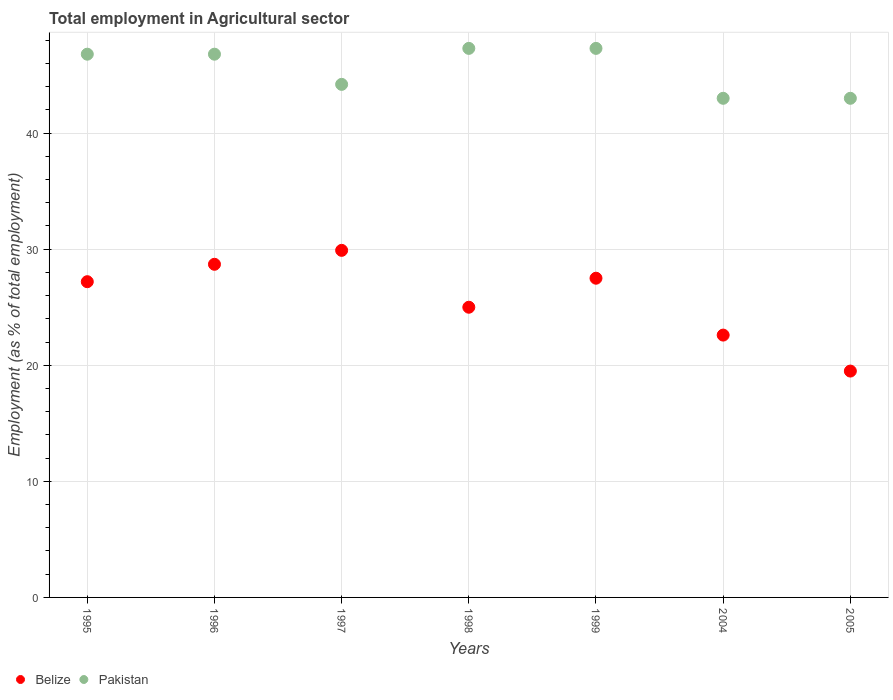Is the number of dotlines equal to the number of legend labels?
Offer a very short reply. Yes. What is the employment in agricultural sector in Pakistan in 1998?
Your answer should be compact. 47.3. Across all years, what is the maximum employment in agricultural sector in Belize?
Give a very brief answer. 29.9. Across all years, what is the minimum employment in agricultural sector in Belize?
Your answer should be very brief. 19.5. In which year was the employment in agricultural sector in Belize maximum?
Your answer should be compact. 1997. In which year was the employment in agricultural sector in Belize minimum?
Your response must be concise. 2005. What is the total employment in agricultural sector in Pakistan in the graph?
Your answer should be compact. 318.4. What is the difference between the employment in agricultural sector in Belize in 1995 and that in 1999?
Make the answer very short. -0.3. What is the difference between the employment in agricultural sector in Pakistan in 1998 and the employment in agricultural sector in Belize in 1996?
Keep it short and to the point. 18.6. What is the average employment in agricultural sector in Belize per year?
Keep it short and to the point. 25.77. In the year 1995, what is the difference between the employment in agricultural sector in Belize and employment in agricultural sector in Pakistan?
Keep it short and to the point. -19.6. What is the ratio of the employment in agricultural sector in Belize in 1995 to that in 1999?
Offer a terse response. 0.99. What is the difference between the highest and the second highest employment in agricultural sector in Belize?
Ensure brevity in your answer.  1.2. What is the difference between the highest and the lowest employment in agricultural sector in Belize?
Offer a terse response. 10.4. In how many years, is the employment in agricultural sector in Pakistan greater than the average employment in agricultural sector in Pakistan taken over all years?
Your answer should be very brief. 4. Is the employment in agricultural sector in Belize strictly greater than the employment in agricultural sector in Pakistan over the years?
Give a very brief answer. No. How many years are there in the graph?
Your answer should be compact. 7. What is the difference between two consecutive major ticks on the Y-axis?
Provide a succinct answer. 10. Are the values on the major ticks of Y-axis written in scientific E-notation?
Offer a very short reply. No. Where does the legend appear in the graph?
Your answer should be very brief. Bottom left. How are the legend labels stacked?
Make the answer very short. Horizontal. What is the title of the graph?
Make the answer very short. Total employment in Agricultural sector. What is the label or title of the X-axis?
Offer a very short reply. Years. What is the label or title of the Y-axis?
Keep it short and to the point. Employment (as % of total employment). What is the Employment (as % of total employment) of Belize in 1995?
Your answer should be compact. 27.2. What is the Employment (as % of total employment) of Pakistan in 1995?
Ensure brevity in your answer.  46.8. What is the Employment (as % of total employment) in Belize in 1996?
Your answer should be compact. 28.7. What is the Employment (as % of total employment) in Pakistan in 1996?
Offer a very short reply. 46.8. What is the Employment (as % of total employment) of Belize in 1997?
Provide a short and direct response. 29.9. What is the Employment (as % of total employment) in Pakistan in 1997?
Provide a short and direct response. 44.2. What is the Employment (as % of total employment) in Pakistan in 1998?
Offer a terse response. 47.3. What is the Employment (as % of total employment) of Pakistan in 1999?
Your answer should be compact. 47.3. What is the Employment (as % of total employment) in Belize in 2004?
Offer a terse response. 22.6. What is the Employment (as % of total employment) of Pakistan in 2004?
Ensure brevity in your answer.  43. What is the Employment (as % of total employment) of Belize in 2005?
Your response must be concise. 19.5. Across all years, what is the maximum Employment (as % of total employment) of Belize?
Your response must be concise. 29.9. Across all years, what is the maximum Employment (as % of total employment) in Pakistan?
Offer a terse response. 47.3. Across all years, what is the minimum Employment (as % of total employment) of Belize?
Offer a very short reply. 19.5. Across all years, what is the minimum Employment (as % of total employment) of Pakistan?
Provide a succinct answer. 43. What is the total Employment (as % of total employment) of Belize in the graph?
Provide a short and direct response. 180.4. What is the total Employment (as % of total employment) in Pakistan in the graph?
Give a very brief answer. 318.4. What is the difference between the Employment (as % of total employment) of Belize in 1995 and that in 1996?
Offer a very short reply. -1.5. What is the difference between the Employment (as % of total employment) in Pakistan in 1995 and that in 1996?
Ensure brevity in your answer.  0. What is the difference between the Employment (as % of total employment) of Belize in 1995 and that in 1997?
Keep it short and to the point. -2.7. What is the difference between the Employment (as % of total employment) in Belize in 1995 and that in 1998?
Offer a terse response. 2.2. What is the difference between the Employment (as % of total employment) of Belize in 1995 and that in 1999?
Offer a terse response. -0.3. What is the difference between the Employment (as % of total employment) in Pakistan in 1995 and that in 1999?
Ensure brevity in your answer.  -0.5. What is the difference between the Employment (as % of total employment) of Pakistan in 1995 and that in 2004?
Your answer should be compact. 3.8. What is the difference between the Employment (as % of total employment) in Belize in 1995 and that in 2005?
Your answer should be compact. 7.7. What is the difference between the Employment (as % of total employment) of Belize in 1996 and that in 2004?
Make the answer very short. 6.1. What is the difference between the Employment (as % of total employment) of Pakistan in 1996 and that in 2004?
Provide a short and direct response. 3.8. What is the difference between the Employment (as % of total employment) of Belize in 1996 and that in 2005?
Offer a terse response. 9.2. What is the difference between the Employment (as % of total employment) in Pakistan in 1996 and that in 2005?
Offer a terse response. 3.8. What is the difference between the Employment (as % of total employment) of Belize in 1997 and that in 1998?
Offer a terse response. 4.9. What is the difference between the Employment (as % of total employment) of Belize in 1997 and that in 2004?
Offer a terse response. 7.3. What is the difference between the Employment (as % of total employment) in Pakistan in 1997 and that in 2005?
Your answer should be very brief. 1.2. What is the difference between the Employment (as % of total employment) in Belize in 1998 and that in 1999?
Your answer should be compact. -2.5. What is the difference between the Employment (as % of total employment) in Belize in 1999 and that in 2004?
Offer a terse response. 4.9. What is the difference between the Employment (as % of total employment) of Pakistan in 1999 and that in 2004?
Provide a short and direct response. 4.3. What is the difference between the Employment (as % of total employment) of Belize in 2004 and that in 2005?
Provide a short and direct response. 3.1. What is the difference between the Employment (as % of total employment) in Pakistan in 2004 and that in 2005?
Offer a very short reply. 0. What is the difference between the Employment (as % of total employment) of Belize in 1995 and the Employment (as % of total employment) of Pakistan in 1996?
Give a very brief answer. -19.6. What is the difference between the Employment (as % of total employment) in Belize in 1995 and the Employment (as % of total employment) in Pakistan in 1998?
Make the answer very short. -20.1. What is the difference between the Employment (as % of total employment) of Belize in 1995 and the Employment (as % of total employment) of Pakistan in 1999?
Your response must be concise. -20.1. What is the difference between the Employment (as % of total employment) in Belize in 1995 and the Employment (as % of total employment) in Pakistan in 2004?
Your answer should be compact. -15.8. What is the difference between the Employment (as % of total employment) in Belize in 1995 and the Employment (as % of total employment) in Pakistan in 2005?
Make the answer very short. -15.8. What is the difference between the Employment (as % of total employment) in Belize in 1996 and the Employment (as % of total employment) in Pakistan in 1997?
Provide a short and direct response. -15.5. What is the difference between the Employment (as % of total employment) in Belize in 1996 and the Employment (as % of total employment) in Pakistan in 1998?
Provide a succinct answer. -18.6. What is the difference between the Employment (as % of total employment) in Belize in 1996 and the Employment (as % of total employment) in Pakistan in 1999?
Your answer should be very brief. -18.6. What is the difference between the Employment (as % of total employment) in Belize in 1996 and the Employment (as % of total employment) in Pakistan in 2004?
Ensure brevity in your answer.  -14.3. What is the difference between the Employment (as % of total employment) of Belize in 1996 and the Employment (as % of total employment) of Pakistan in 2005?
Your response must be concise. -14.3. What is the difference between the Employment (as % of total employment) in Belize in 1997 and the Employment (as % of total employment) in Pakistan in 1998?
Keep it short and to the point. -17.4. What is the difference between the Employment (as % of total employment) of Belize in 1997 and the Employment (as % of total employment) of Pakistan in 1999?
Offer a terse response. -17.4. What is the difference between the Employment (as % of total employment) of Belize in 1997 and the Employment (as % of total employment) of Pakistan in 2004?
Make the answer very short. -13.1. What is the difference between the Employment (as % of total employment) of Belize in 1997 and the Employment (as % of total employment) of Pakistan in 2005?
Offer a terse response. -13.1. What is the difference between the Employment (as % of total employment) of Belize in 1998 and the Employment (as % of total employment) of Pakistan in 1999?
Your response must be concise. -22.3. What is the difference between the Employment (as % of total employment) in Belize in 1998 and the Employment (as % of total employment) in Pakistan in 2004?
Give a very brief answer. -18. What is the difference between the Employment (as % of total employment) in Belize in 1999 and the Employment (as % of total employment) in Pakistan in 2004?
Keep it short and to the point. -15.5. What is the difference between the Employment (as % of total employment) in Belize in 1999 and the Employment (as % of total employment) in Pakistan in 2005?
Provide a succinct answer. -15.5. What is the difference between the Employment (as % of total employment) in Belize in 2004 and the Employment (as % of total employment) in Pakistan in 2005?
Ensure brevity in your answer.  -20.4. What is the average Employment (as % of total employment) in Belize per year?
Give a very brief answer. 25.77. What is the average Employment (as % of total employment) of Pakistan per year?
Your answer should be compact. 45.49. In the year 1995, what is the difference between the Employment (as % of total employment) of Belize and Employment (as % of total employment) of Pakistan?
Your answer should be compact. -19.6. In the year 1996, what is the difference between the Employment (as % of total employment) in Belize and Employment (as % of total employment) in Pakistan?
Ensure brevity in your answer.  -18.1. In the year 1997, what is the difference between the Employment (as % of total employment) in Belize and Employment (as % of total employment) in Pakistan?
Offer a terse response. -14.3. In the year 1998, what is the difference between the Employment (as % of total employment) in Belize and Employment (as % of total employment) in Pakistan?
Provide a short and direct response. -22.3. In the year 1999, what is the difference between the Employment (as % of total employment) in Belize and Employment (as % of total employment) in Pakistan?
Give a very brief answer. -19.8. In the year 2004, what is the difference between the Employment (as % of total employment) of Belize and Employment (as % of total employment) of Pakistan?
Offer a very short reply. -20.4. In the year 2005, what is the difference between the Employment (as % of total employment) of Belize and Employment (as % of total employment) of Pakistan?
Give a very brief answer. -23.5. What is the ratio of the Employment (as % of total employment) of Belize in 1995 to that in 1996?
Keep it short and to the point. 0.95. What is the ratio of the Employment (as % of total employment) in Belize in 1995 to that in 1997?
Your answer should be compact. 0.91. What is the ratio of the Employment (as % of total employment) of Pakistan in 1995 to that in 1997?
Make the answer very short. 1.06. What is the ratio of the Employment (as % of total employment) in Belize in 1995 to that in 1998?
Keep it short and to the point. 1.09. What is the ratio of the Employment (as % of total employment) in Pakistan in 1995 to that in 1998?
Keep it short and to the point. 0.99. What is the ratio of the Employment (as % of total employment) in Belize in 1995 to that in 1999?
Your answer should be compact. 0.99. What is the ratio of the Employment (as % of total employment) of Pakistan in 1995 to that in 1999?
Your answer should be very brief. 0.99. What is the ratio of the Employment (as % of total employment) of Belize in 1995 to that in 2004?
Make the answer very short. 1.2. What is the ratio of the Employment (as % of total employment) in Pakistan in 1995 to that in 2004?
Your response must be concise. 1.09. What is the ratio of the Employment (as % of total employment) of Belize in 1995 to that in 2005?
Make the answer very short. 1.39. What is the ratio of the Employment (as % of total employment) in Pakistan in 1995 to that in 2005?
Keep it short and to the point. 1.09. What is the ratio of the Employment (as % of total employment) of Belize in 1996 to that in 1997?
Your response must be concise. 0.96. What is the ratio of the Employment (as % of total employment) of Pakistan in 1996 to that in 1997?
Provide a succinct answer. 1.06. What is the ratio of the Employment (as % of total employment) in Belize in 1996 to that in 1998?
Your response must be concise. 1.15. What is the ratio of the Employment (as % of total employment) in Belize in 1996 to that in 1999?
Give a very brief answer. 1.04. What is the ratio of the Employment (as % of total employment) of Pakistan in 1996 to that in 1999?
Your response must be concise. 0.99. What is the ratio of the Employment (as % of total employment) of Belize in 1996 to that in 2004?
Offer a very short reply. 1.27. What is the ratio of the Employment (as % of total employment) of Pakistan in 1996 to that in 2004?
Offer a very short reply. 1.09. What is the ratio of the Employment (as % of total employment) in Belize in 1996 to that in 2005?
Keep it short and to the point. 1.47. What is the ratio of the Employment (as % of total employment) in Pakistan in 1996 to that in 2005?
Ensure brevity in your answer.  1.09. What is the ratio of the Employment (as % of total employment) in Belize in 1997 to that in 1998?
Offer a very short reply. 1.2. What is the ratio of the Employment (as % of total employment) of Pakistan in 1997 to that in 1998?
Your answer should be compact. 0.93. What is the ratio of the Employment (as % of total employment) of Belize in 1997 to that in 1999?
Make the answer very short. 1.09. What is the ratio of the Employment (as % of total employment) in Pakistan in 1997 to that in 1999?
Your answer should be very brief. 0.93. What is the ratio of the Employment (as % of total employment) in Belize in 1997 to that in 2004?
Keep it short and to the point. 1.32. What is the ratio of the Employment (as % of total employment) in Pakistan in 1997 to that in 2004?
Your response must be concise. 1.03. What is the ratio of the Employment (as % of total employment) of Belize in 1997 to that in 2005?
Offer a terse response. 1.53. What is the ratio of the Employment (as % of total employment) of Pakistan in 1997 to that in 2005?
Ensure brevity in your answer.  1.03. What is the ratio of the Employment (as % of total employment) in Pakistan in 1998 to that in 1999?
Your answer should be very brief. 1. What is the ratio of the Employment (as % of total employment) in Belize in 1998 to that in 2004?
Your response must be concise. 1.11. What is the ratio of the Employment (as % of total employment) of Belize in 1998 to that in 2005?
Offer a terse response. 1.28. What is the ratio of the Employment (as % of total employment) of Belize in 1999 to that in 2004?
Offer a very short reply. 1.22. What is the ratio of the Employment (as % of total employment) of Belize in 1999 to that in 2005?
Give a very brief answer. 1.41. What is the ratio of the Employment (as % of total employment) in Pakistan in 1999 to that in 2005?
Make the answer very short. 1.1. What is the ratio of the Employment (as % of total employment) in Belize in 2004 to that in 2005?
Give a very brief answer. 1.16. What is the ratio of the Employment (as % of total employment) in Pakistan in 2004 to that in 2005?
Offer a very short reply. 1. What is the difference between the highest and the second highest Employment (as % of total employment) of Belize?
Provide a succinct answer. 1.2. What is the difference between the highest and the second highest Employment (as % of total employment) of Pakistan?
Keep it short and to the point. 0. 